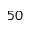Convert formula to latex. <formula><loc_0><loc_0><loc_500><loc_500>5 0</formula> 